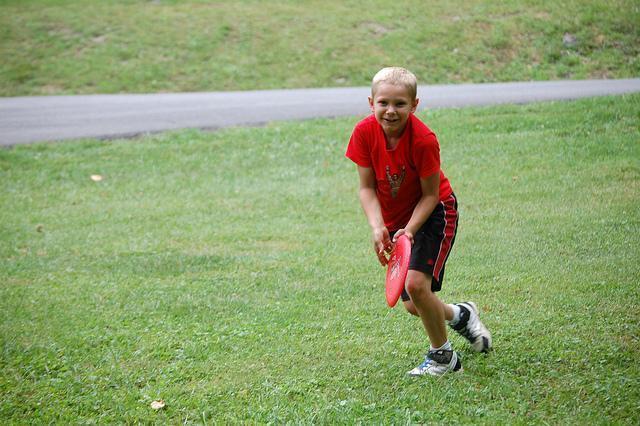How many people are there?
Give a very brief answer. 1. How many suitcases are there?
Give a very brief answer. 0. 